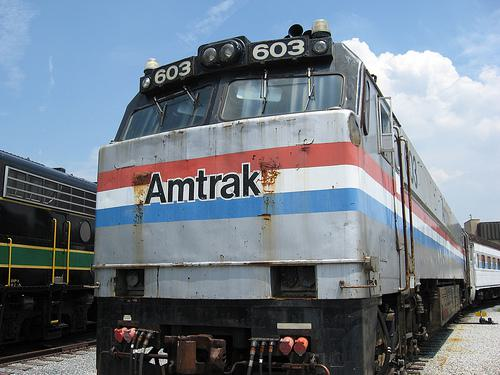What type of vehicle is this? This is a locomotive used for pulling trains, specifically an Amtrak passenger locomotive. Can you tell me about its design and color scheme? Certainly! It features a classic Amtrak livery with a predominantly silver body accented with a red and blue stripe, reflecting Amtrak's corporate colors during the era it was in service. The model number '603' can be seen at the top. 